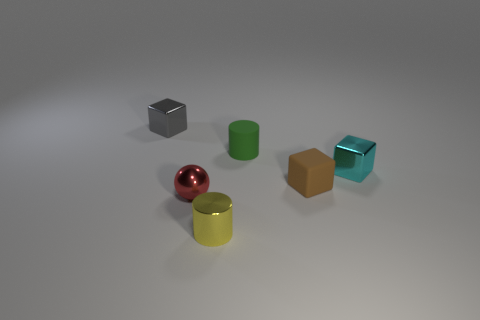Add 3 cyan metal balls. How many objects exist? 9 Subtract all cylinders. How many objects are left? 4 Subtract all tiny yellow cylinders. Subtract all metal spheres. How many objects are left? 4 Add 5 metal objects. How many metal objects are left? 9 Add 6 blue rubber spheres. How many blue rubber spheres exist? 6 Subtract 0 red cubes. How many objects are left? 6 